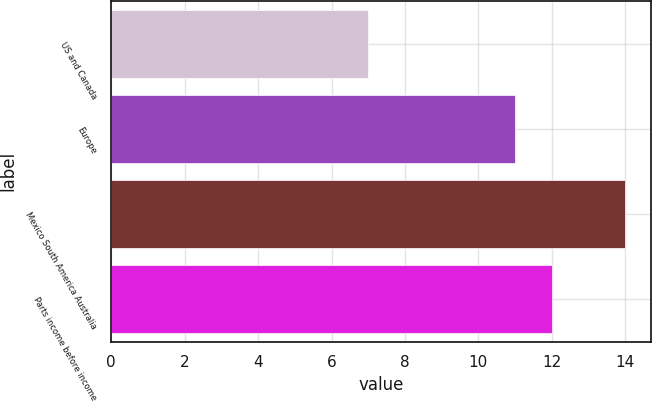Convert chart to OTSL. <chart><loc_0><loc_0><loc_500><loc_500><bar_chart><fcel>US and Canada<fcel>Europe<fcel>Mexico South America Australia<fcel>Parts income before income<nl><fcel>7<fcel>11<fcel>14<fcel>12<nl></chart> 